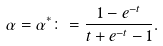<formula> <loc_0><loc_0><loc_500><loc_500>\alpha = \alpha ^ { * } \colon = \frac { 1 - e ^ { - t } } { t + e ^ { - t } - 1 } .</formula> 